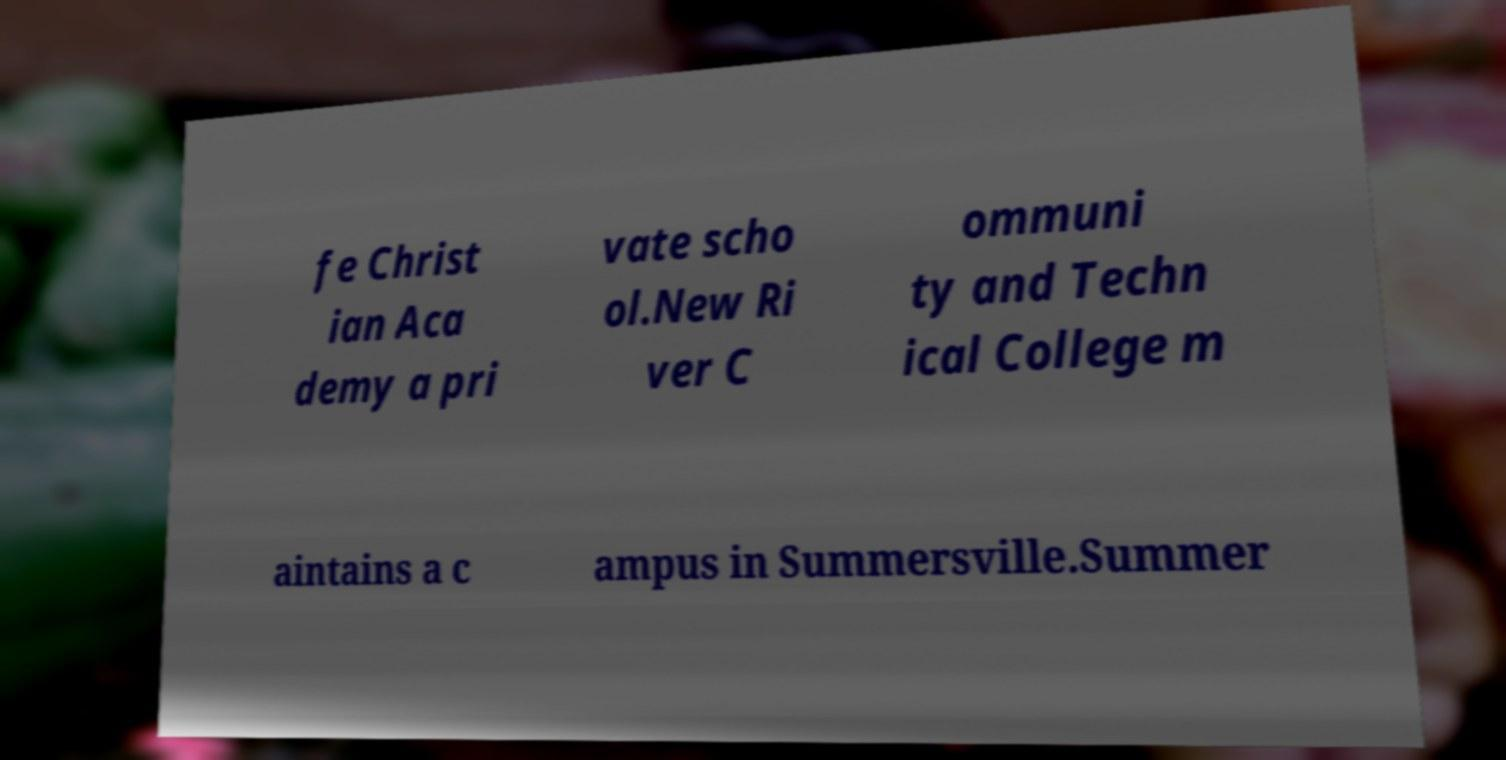Can you read and provide the text displayed in the image?This photo seems to have some interesting text. Can you extract and type it out for me? fe Christ ian Aca demy a pri vate scho ol.New Ri ver C ommuni ty and Techn ical College m aintains a c ampus in Summersville.Summer 